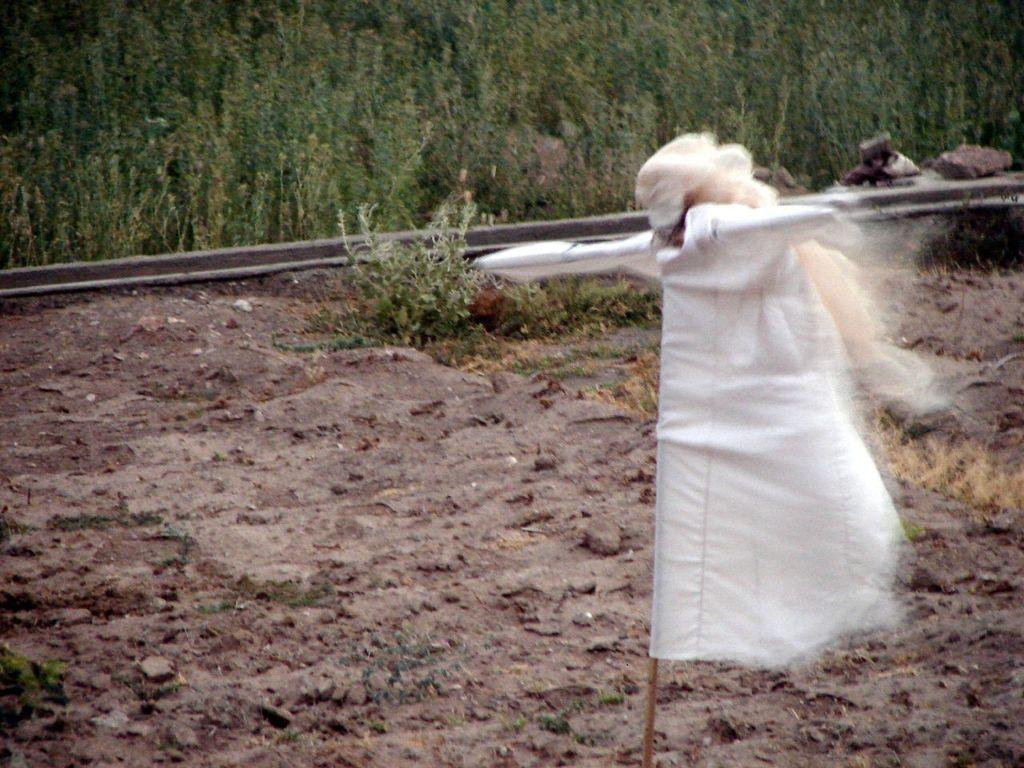What is the main subject of the image? There is a scarecrow in the image. What can be seen in the background of the image? There are plants in the background of the image. What is the ground made of in the image? Soil is visible at the bottom of the image. What type of thread is being used to sew the idea onto the scarecrow in the image? There is no thread or idea present in the image; it features a scarecrow and plants in the background. 